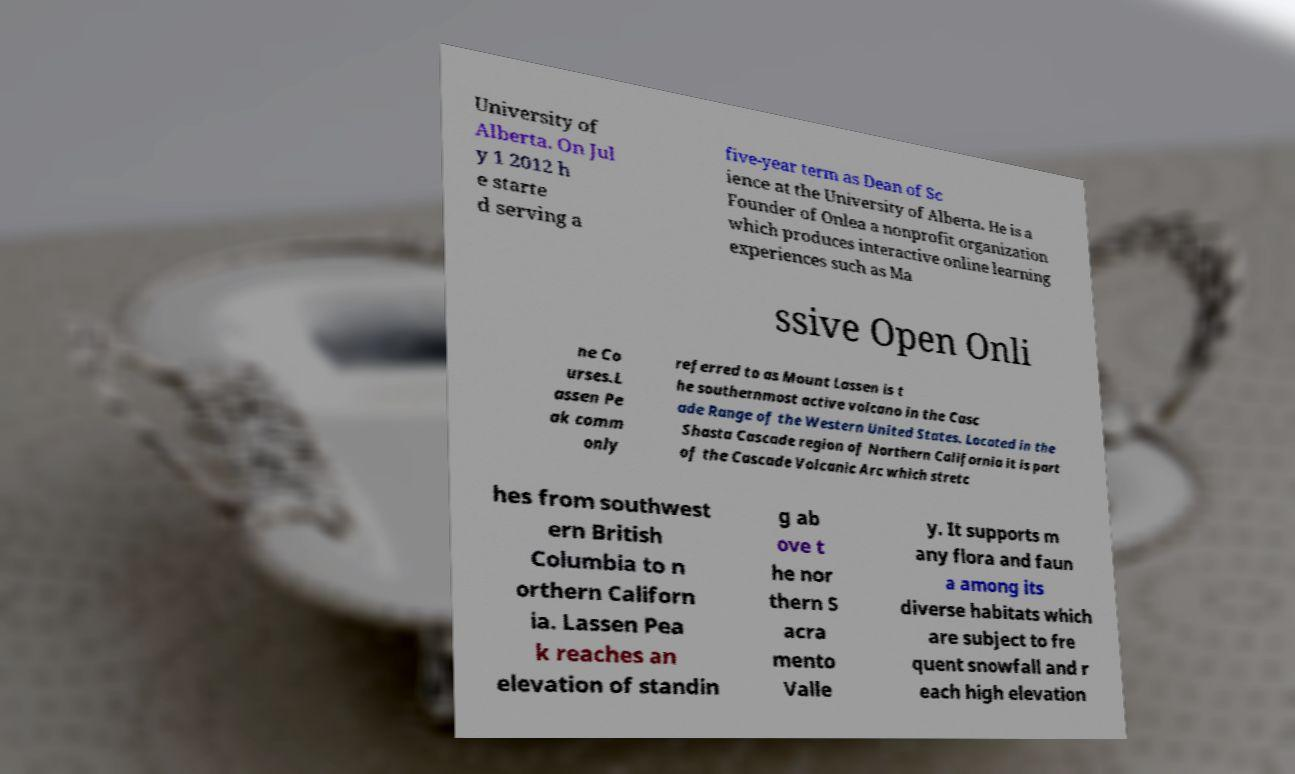Could you assist in decoding the text presented in this image and type it out clearly? University of Alberta. On Jul y 1 2012 h e starte d serving a five-year term as Dean of Sc ience at the University of Alberta. He is a Founder of Onlea a nonprofit organization which produces interactive online learning experiences such as Ma ssive Open Onli ne Co urses.L assen Pe ak comm only referred to as Mount Lassen is t he southernmost active volcano in the Casc ade Range of the Western United States. Located in the Shasta Cascade region of Northern California it is part of the Cascade Volcanic Arc which stretc hes from southwest ern British Columbia to n orthern Californ ia. Lassen Pea k reaches an elevation of standin g ab ove t he nor thern S acra mento Valle y. It supports m any flora and faun a among its diverse habitats which are subject to fre quent snowfall and r each high elevation 